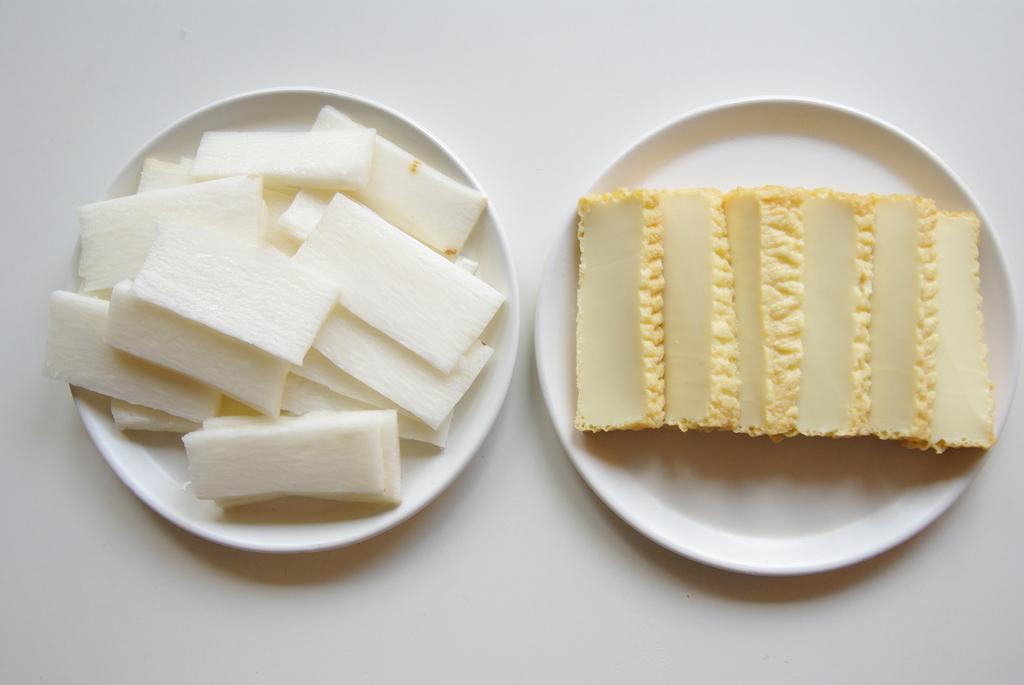How would you summarize this image in a sentence or two? In this picture we can see some food in plates. 